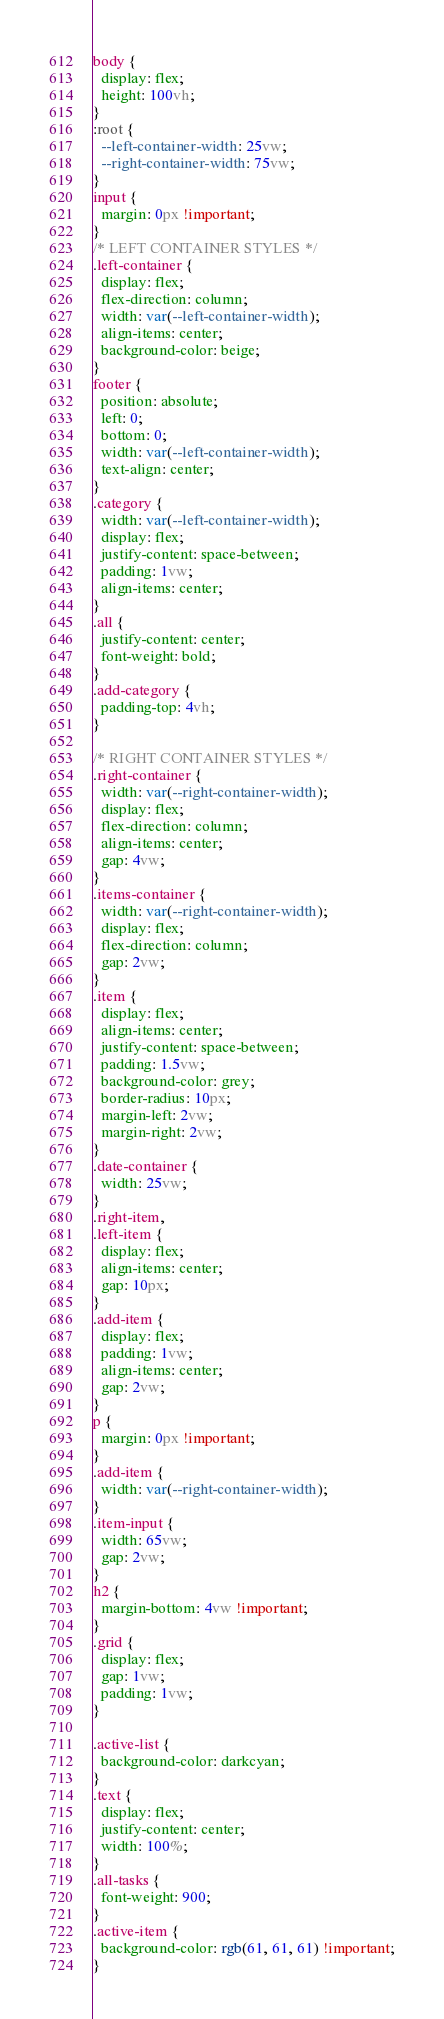<code> <loc_0><loc_0><loc_500><loc_500><_CSS_>body {
  display: flex;
  height: 100vh;
}
:root {
  --left-container-width: 25vw;
  --right-container-width: 75vw;
}
input {
  margin: 0px !important;
}
/* LEFT CONTAINER STYLES */
.left-container {
  display: flex;
  flex-direction: column;
  width: var(--left-container-width);
  align-items: center;
  background-color: beige;
}
footer {
  position: absolute;
  left: 0;
  bottom: 0;
  width: var(--left-container-width);
  text-align: center;
}
.category {
  width: var(--left-container-width);
  display: flex;
  justify-content: space-between;
  padding: 1vw;
  align-items: center;
}
.all {
  justify-content: center;
  font-weight: bold;
}
.add-category {
  padding-top: 4vh;
}

/* RIGHT CONTAINER STYLES */
.right-container {
  width: var(--right-container-width);
  display: flex;
  flex-direction: column;
  align-items: center;
  gap: 4vw;
}
.items-container {
  width: var(--right-container-width);
  display: flex;
  flex-direction: column;
  gap: 2vw;
}
.item {
  display: flex;
  align-items: center;
  justify-content: space-between;
  padding: 1.5vw;
  background-color: grey;
  border-radius: 10px;
  margin-left: 2vw;
  margin-right: 2vw;
}
.date-container {
  width: 25vw;
}
.right-item,
.left-item {
  display: flex;
  align-items: center;
  gap: 10px;
}
.add-item {
  display: flex;
  padding: 1vw;
  align-items: center;
  gap: 2vw;
}
p {
  margin: 0px !important;
}
.add-item {
  width: var(--right-container-width);
}
.item-input {
  width: 65vw;
  gap: 2vw;
}
h2 {
  margin-bottom: 4vw !important;
}
.grid {
  display: flex;
  gap: 1vw;
  padding: 1vw;
}

.active-list {
  background-color: darkcyan;
}
.text {
  display: flex;
  justify-content: center;
  width: 100%;
}
.all-tasks {
  font-weight: 900;
}
.active-item {
  background-color: rgb(61, 61, 61) !important;
}
</code> 